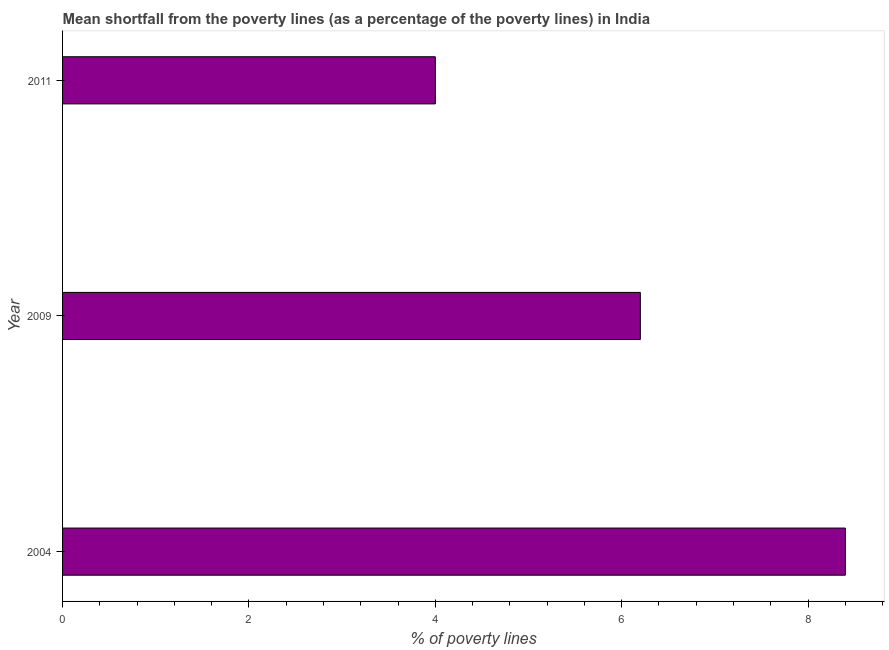What is the title of the graph?
Keep it short and to the point. Mean shortfall from the poverty lines (as a percentage of the poverty lines) in India. What is the label or title of the X-axis?
Your answer should be compact. % of poverty lines. Across all years, what is the minimum poverty gap at national poverty lines?
Your answer should be very brief. 4. In which year was the poverty gap at national poverty lines maximum?
Make the answer very short. 2004. In which year was the poverty gap at national poverty lines minimum?
Offer a terse response. 2011. What is the sum of the poverty gap at national poverty lines?
Provide a succinct answer. 18.6. Do a majority of the years between 2009 and 2011 (inclusive) have poverty gap at national poverty lines greater than 1.2 %?
Ensure brevity in your answer.  Yes. What is the ratio of the poverty gap at national poverty lines in 2009 to that in 2011?
Offer a very short reply. 1.55. Is the difference between the poverty gap at national poverty lines in 2004 and 2009 greater than the difference between any two years?
Your response must be concise. No. Is the sum of the poverty gap at national poverty lines in 2004 and 2009 greater than the maximum poverty gap at national poverty lines across all years?
Keep it short and to the point. Yes. What is the difference between the highest and the lowest poverty gap at national poverty lines?
Provide a succinct answer. 4.4. In how many years, is the poverty gap at national poverty lines greater than the average poverty gap at national poverty lines taken over all years?
Your answer should be compact. 1. Are all the bars in the graph horizontal?
Offer a very short reply. Yes. How many years are there in the graph?
Keep it short and to the point. 3. What is the % of poverty lines in 2009?
Your answer should be very brief. 6.2. What is the % of poverty lines of 2011?
Offer a terse response. 4. What is the difference between the % of poverty lines in 2004 and 2011?
Your answer should be very brief. 4.4. What is the ratio of the % of poverty lines in 2004 to that in 2009?
Your response must be concise. 1.35. What is the ratio of the % of poverty lines in 2009 to that in 2011?
Provide a succinct answer. 1.55. 